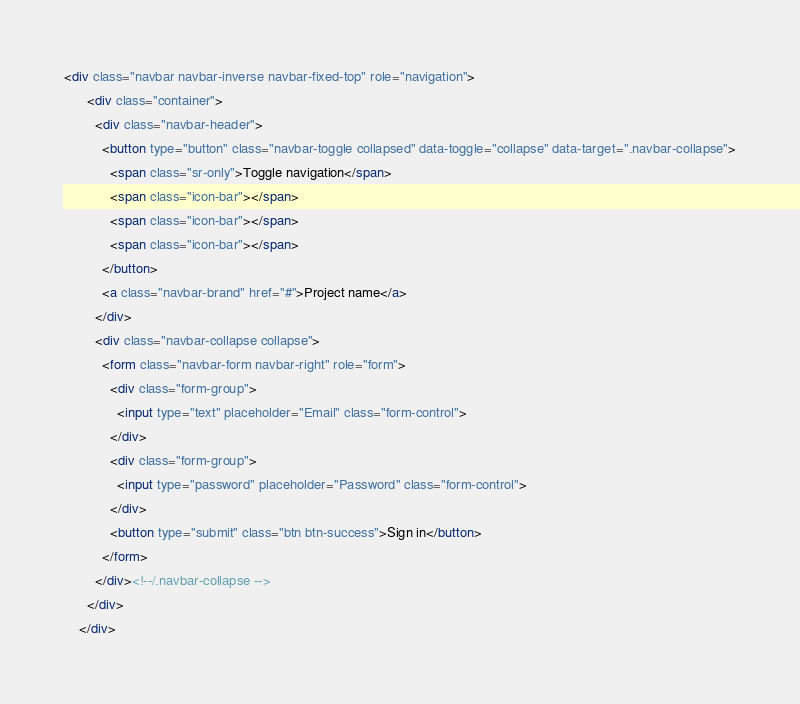<code> <loc_0><loc_0><loc_500><loc_500><_HTML_><div class="navbar navbar-inverse navbar-fixed-top" role="navigation">
      <div class="container">
        <div class="navbar-header">
          <button type="button" class="navbar-toggle collapsed" data-toggle="collapse" data-target=".navbar-collapse">
            <span class="sr-only">Toggle navigation</span>
            <span class="icon-bar"></span>
            <span class="icon-bar"></span>
            <span class="icon-bar"></span>
          </button>
          <a class="navbar-brand" href="#">Project name</a>
        </div>
        <div class="navbar-collapse collapse">
          <form class="navbar-form navbar-right" role="form">
            <div class="form-group">
              <input type="text" placeholder="Email" class="form-control">
            </div>
            <div class="form-group">
              <input type="password" placeholder="Password" class="form-control">
            </div>
            <button type="submit" class="btn btn-success">Sign in</button>
          </form>
        </div><!--/.navbar-collapse -->
      </div>
    </div></code> 